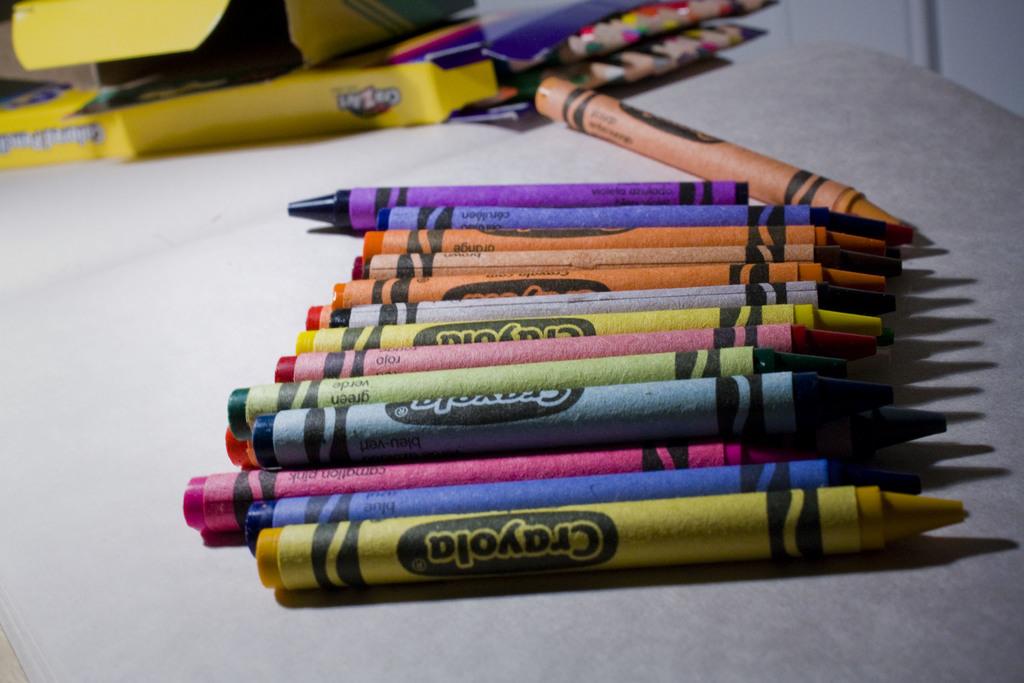Which brand are the crayons?
Your answer should be very brief. Crayola. What brand name are these coloring apparatuses?
Offer a terse response. Crayola. 